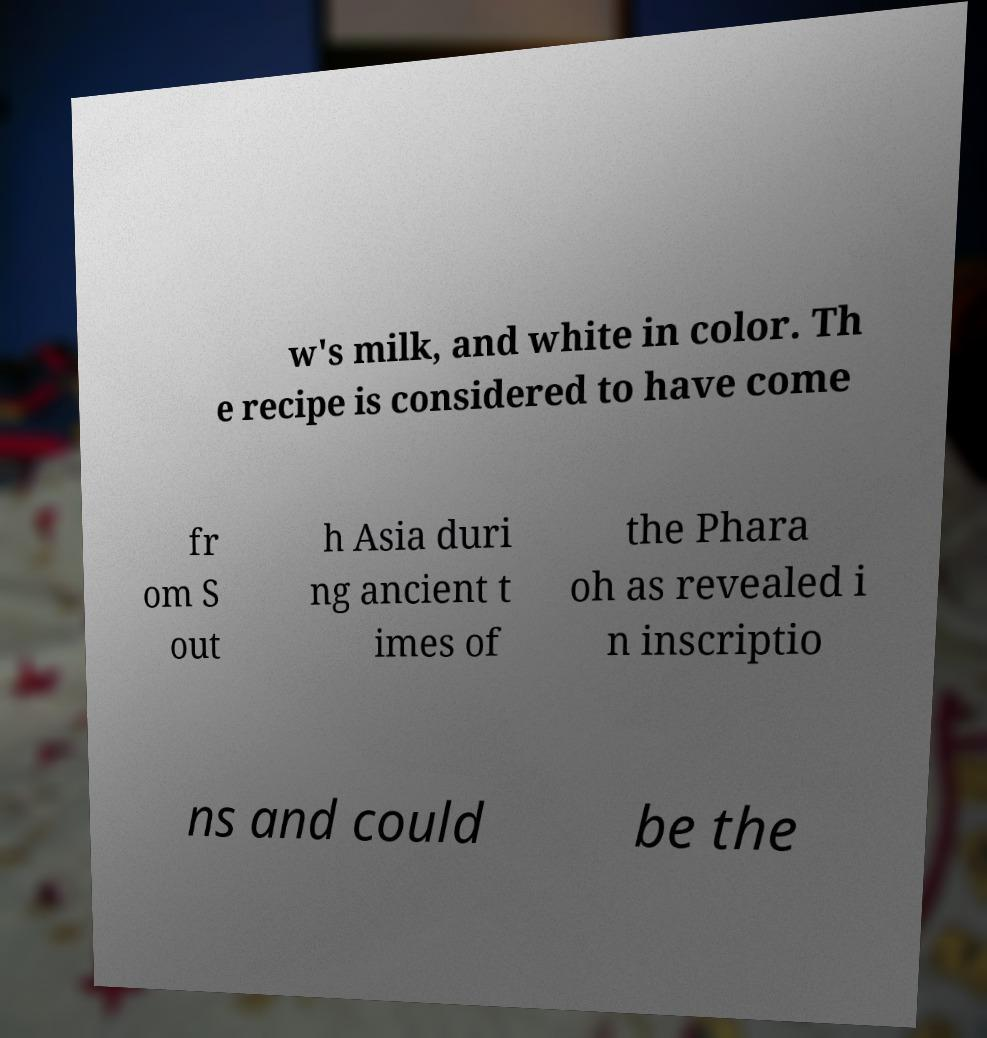Can you read and provide the text displayed in the image?This photo seems to have some interesting text. Can you extract and type it out for me? w's milk, and white in color. Th e recipe is considered to have come fr om S out h Asia duri ng ancient t imes of the Phara oh as revealed i n inscriptio ns and could be the 